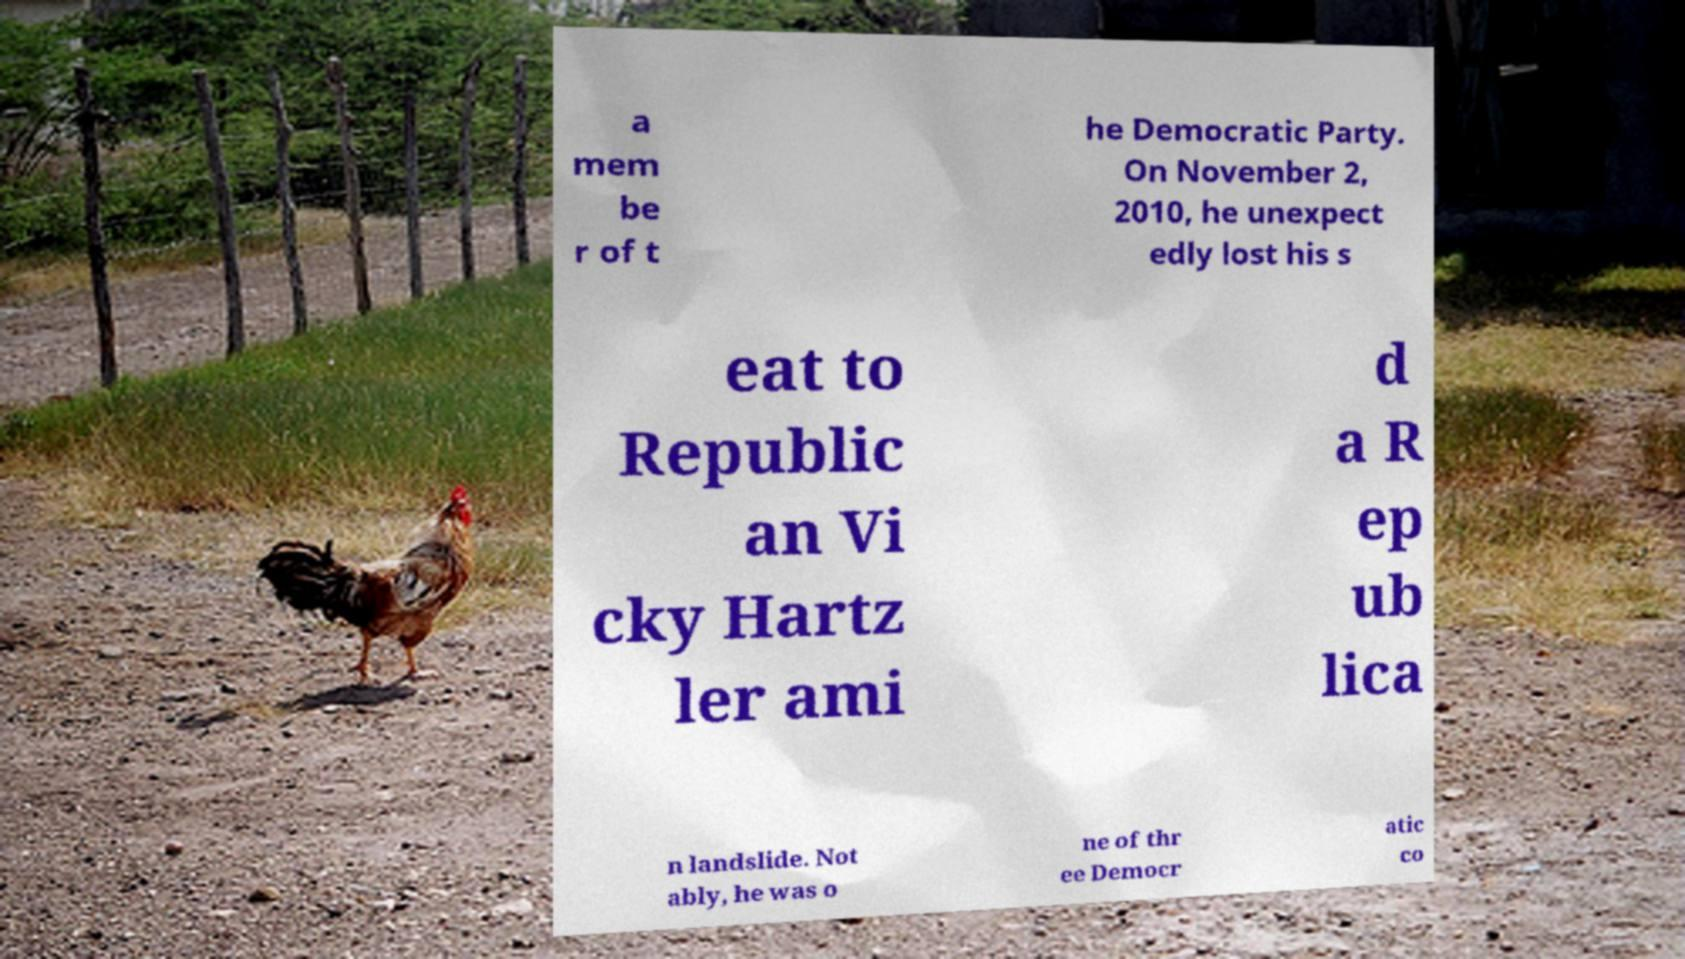There's text embedded in this image that I need extracted. Can you transcribe it verbatim? a mem be r of t he Democratic Party. On November 2, 2010, he unexpect edly lost his s eat to Republic an Vi cky Hartz ler ami d a R ep ub lica n landslide. Not ably, he was o ne of thr ee Democr atic co 